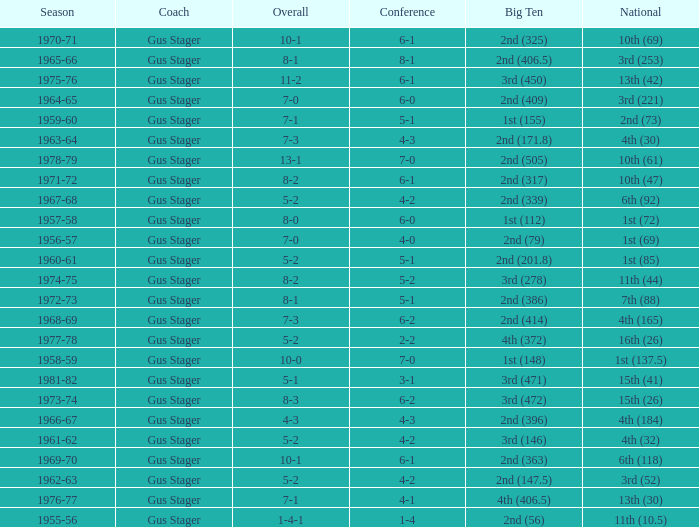Would you be able to parse every entry in this table? {'header': ['Season', 'Coach', 'Overall', 'Conference', 'Big Ten', 'National'], 'rows': [['1970-71', 'Gus Stager', '10-1', '6-1', '2nd (325)', '10th (69)'], ['1965-66', 'Gus Stager', '8-1', '8-1', '2nd (406.5)', '3rd (253)'], ['1975-76', 'Gus Stager', '11-2', '6-1', '3rd (450)', '13th (42)'], ['1964-65', 'Gus Stager', '7-0', '6-0', '2nd (409)', '3rd (221)'], ['1959-60', 'Gus Stager', '7-1', '5-1', '1st (155)', '2nd (73)'], ['1963-64', 'Gus Stager', '7-3', '4-3', '2nd (171.8)', '4th (30)'], ['1978-79', 'Gus Stager', '13-1', '7-0', '2nd (505)', '10th (61)'], ['1971-72', 'Gus Stager', '8-2', '6-1', '2nd (317)', '10th (47)'], ['1967-68', 'Gus Stager', '5-2', '4-2', '2nd (339)', '6th (92)'], ['1957-58', 'Gus Stager', '8-0', '6-0', '1st (112)', '1st (72)'], ['1956-57', 'Gus Stager', '7-0', '4-0', '2nd (79)', '1st (69)'], ['1960-61', 'Gus Stager', '5-2', '5-1', '2nd (201.8)', '1st (85)'], ['1974-75', 'Gus Stager', '8-2', '5-2', '3rd (278)', '11th (44)'], ['1972-73', 'Gus Stager', '8-1', '5-1', '2nd (386)', '7th (88)'], ['1968-69', 'Gus Stager', '7-3', '6-2', '2nd (414)', '4th (165)'], ['1977-78', 'Gus Stager', '5-2', '2-2', '4th (372)', '16th (26)'], ['1958-59', 'Gus Stager', '10-0', '7-0', '1st (148)', '1st (137.5)'], ['1981-82', 'Gus Stager', '5-1', '3-1', '3rd (471)', '15th (41)'], ['1973-74', 'Gus Stager', '8-3', '6-2', '3rd (472)', '15th (26)'], ['1966-67', 'Gus Stager', '4-3', '4-3', '2nd (396)', '4th (184)'], ['1961-62', 'Gus Stager', '5-2', '4-2', '3rd (146)', '4th (32)'], ['1969-70', 'Gus Stager', '10-1', '6-1', '2nd (363)', '6th (118)'], ['1962-63', 'Gus Stager', '5-2', '4-2', '2nd (147.5)', '3rd (52)'], ['1976-77', 'Gus Stager', '7-1', '4-1', '4th (406.5)', '13th (30)'], ['1955-56', 'Gus Stager', '1-4-1', '1-4', '2nd (56)', '11th (10.5)']]} What is the Coach with a Big Ten that is 2nd (79)? Gus Stager. 